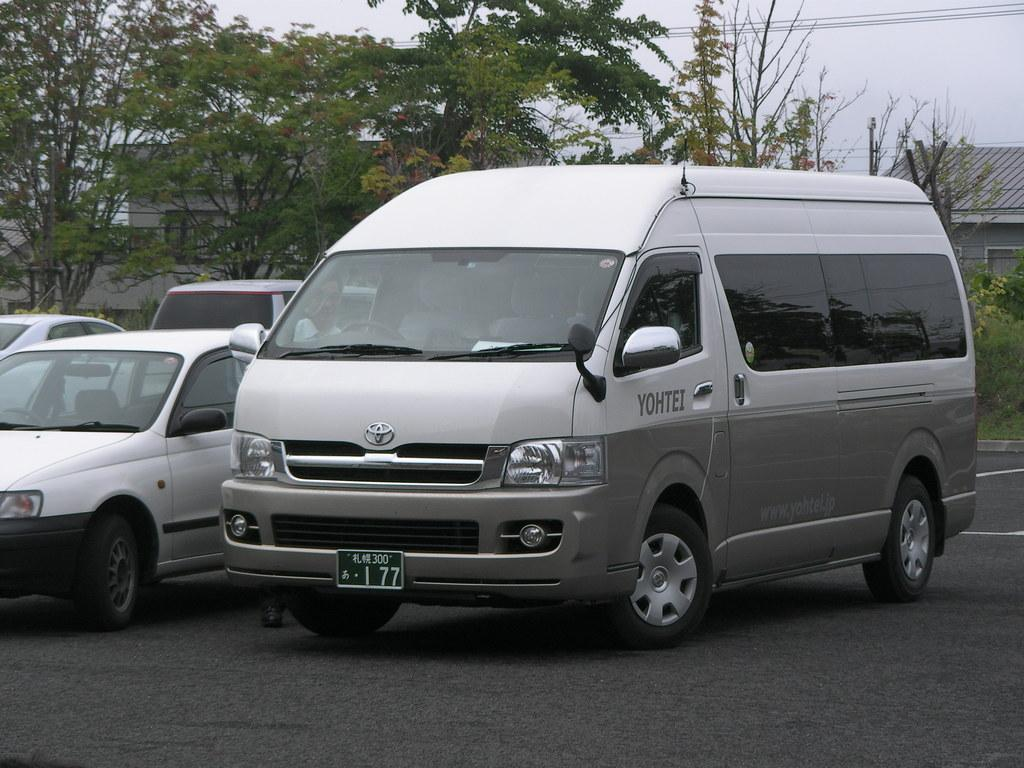<image>
Render a clear and concise summary of the photo. Yohtei is advertised on the side of a Toyota van. 